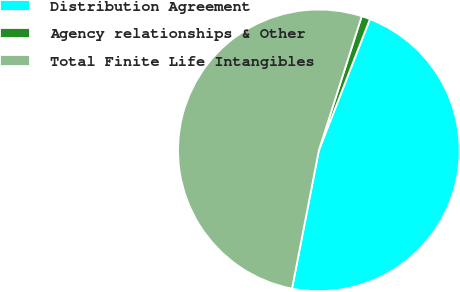Convert chart. <chart><loc_0><loc_0><loc_500><loc_500><pie_chart><fcel>Distribution Agreement<fcel>Agency relationships & Other<fcel>Total Finite Life Intangibles<nl><fcel>47.15%<fcel>0.98%<fcel>51.87%<nl></chart> 